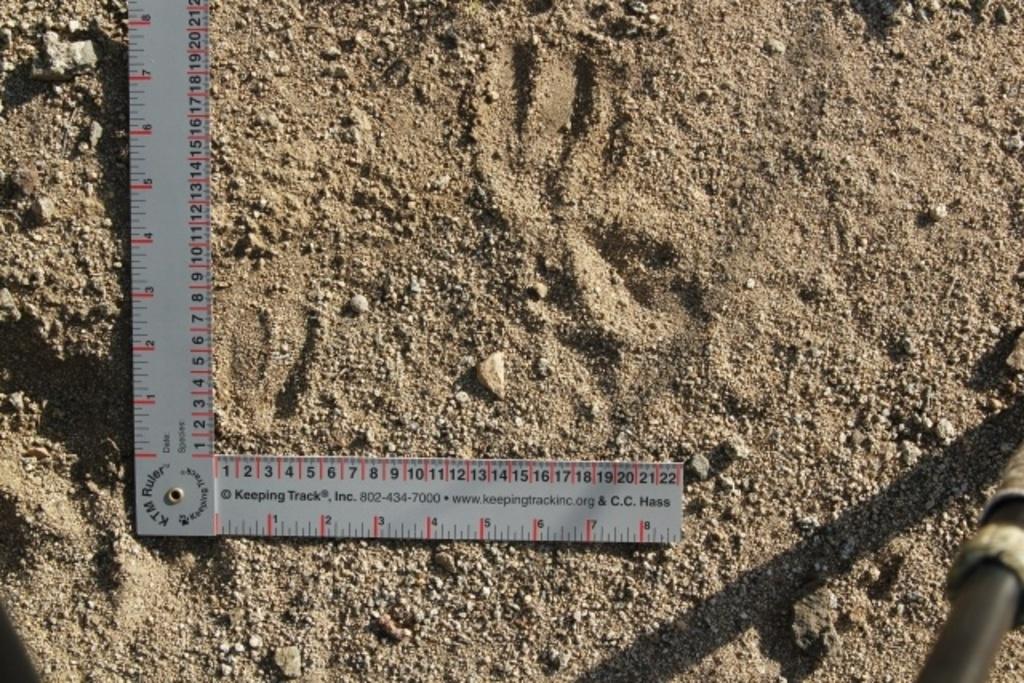What is the website on this?
Offer a terse response. Www.keepingtrackinc.org. What is the phone number?
Ensure brevity in your answer.  802-434-7000. 